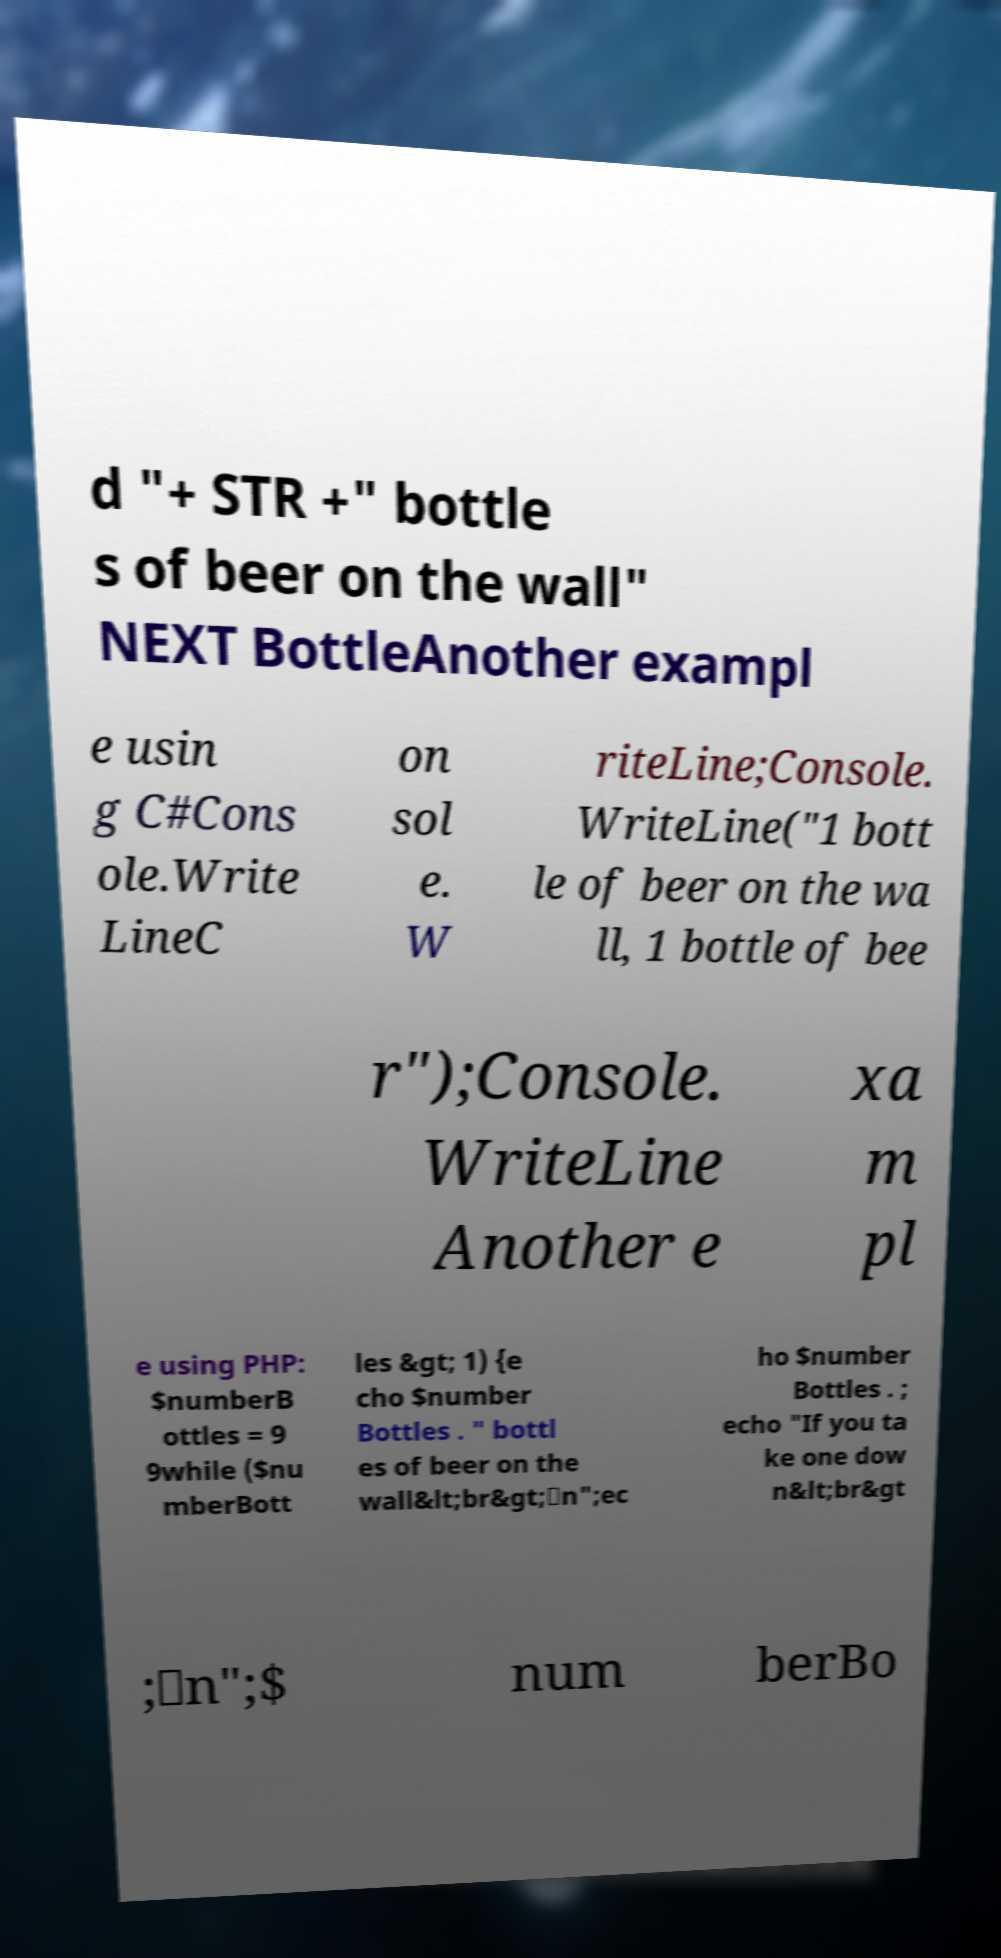I need the written content from this picture converted into text. Can you do that? d "+ STR +" bottle s of beer on the wall" NEXT BottleAnother exampl e usin g C#Cons ole.Write LineC on sol e. W riteLine;Console. WriteLine("1 bott le of beer on the wa ll, 1 bottle of bee r");Console. WriteLine Another e xa m pl e using PHP: $numberB ottles = 9 9while ($nu mberBott les &gt; 1) {e cho $number Bottles . " bottl es of beer on the wall&lt;br&gt;\n";ec ho $number Bottles . ; echo "If you ta ke one dow n&lt;br&gt ;\n";$ num berBo 